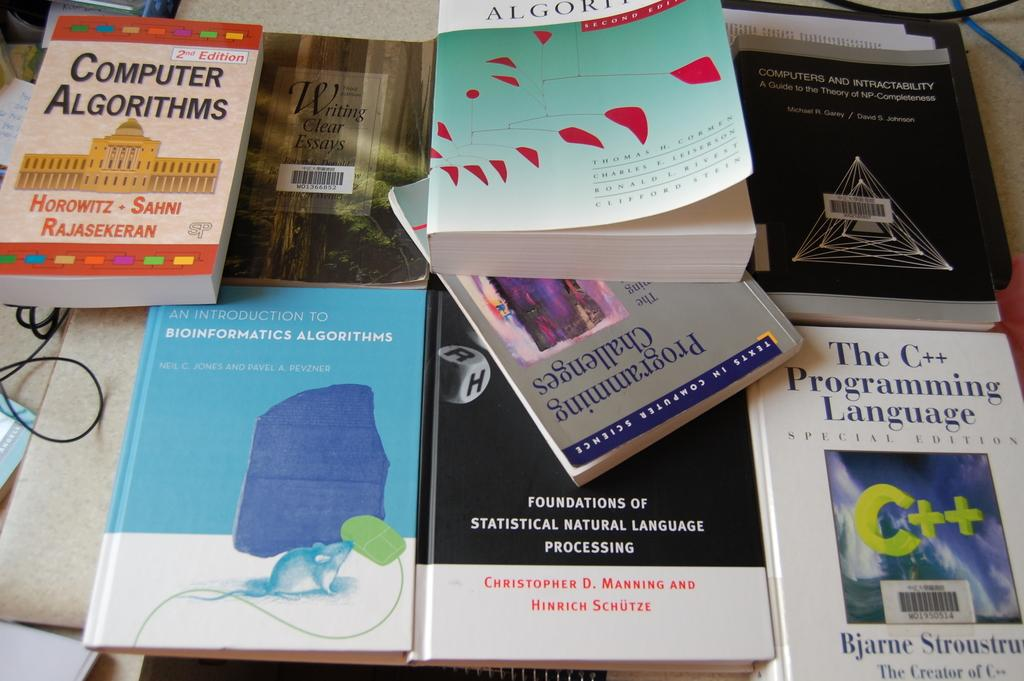What objects are present in large quantities in the image? There are many books in the image. Where are the books located? The books are kept on a surface. What else can be seen in the image besides the books? There are wires visible in the image. What type of meat is being cooked on the grill in the image? There is no grill or meat present in the image; it only features books and wires. What color is the wool that the sheep are wearing in the image? There are no sheep or wool present in the image; it only features books and wires. 